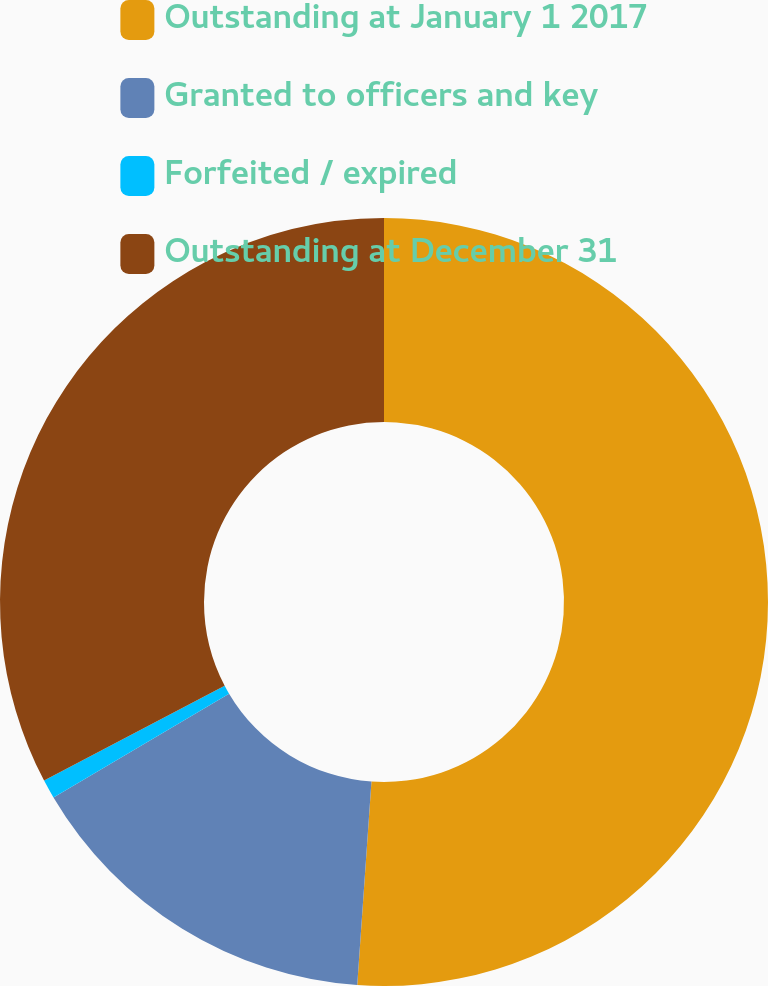Convert chart. <chart><loc_0><loc_0><loc_500><loc_500><pie_chart><fcel>Outstanding at January 1 2017<fcel>Granted to officers and key<fcel>Forfeited / expired<fcel>Outstanding at December 31<nl><fcel>51.11%<fcel>15.39%<fcel>0.8%<fcel>32.7%<nl></chart> 